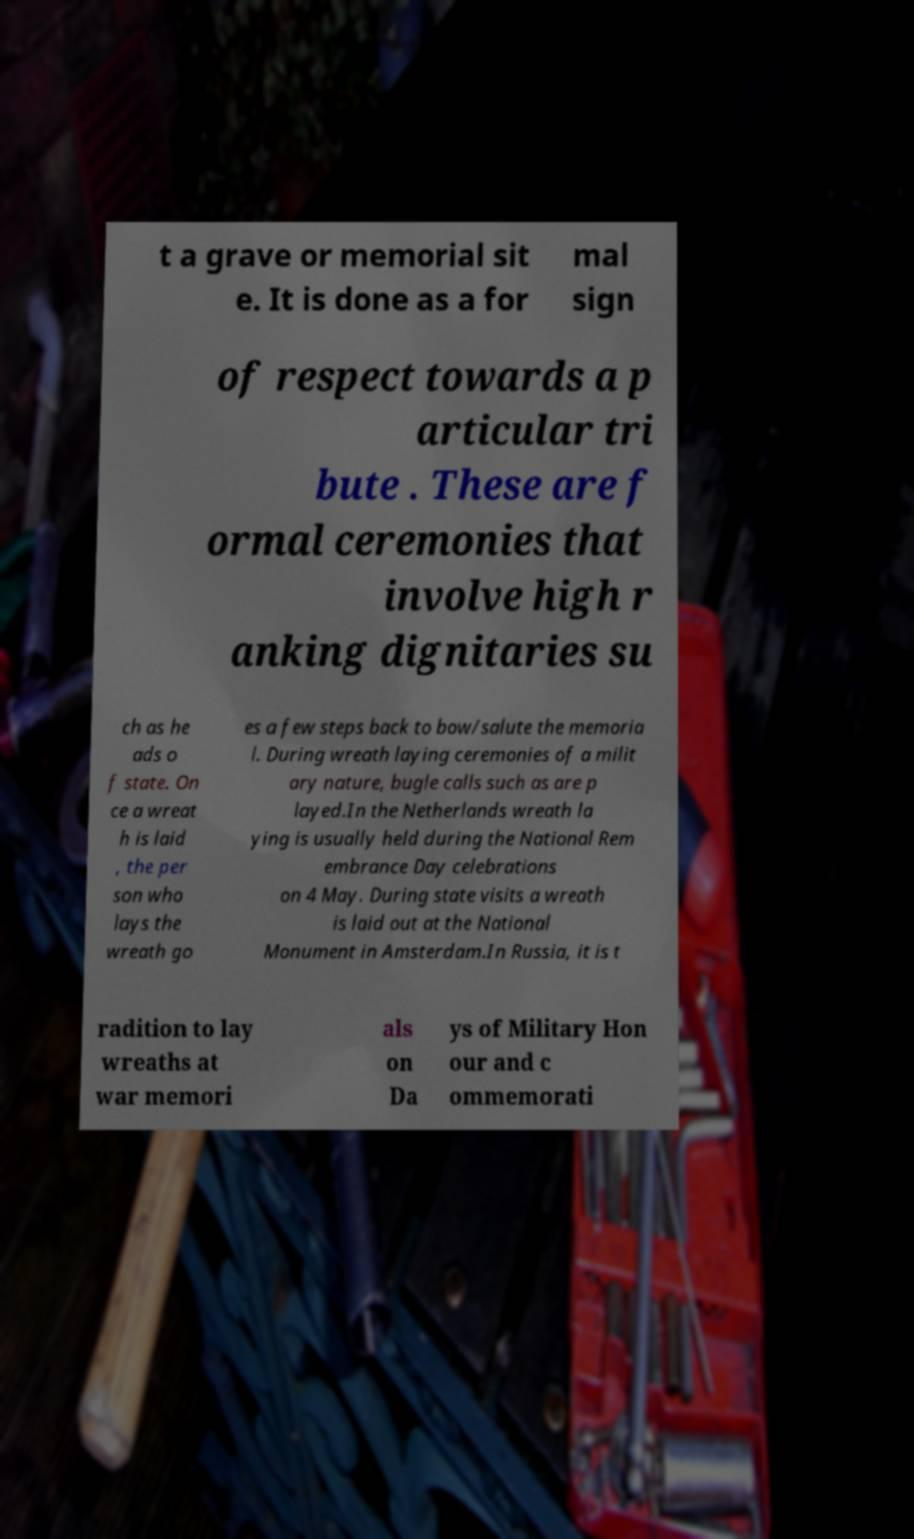Can you accurately transcribe the text from the provided image for me? t a grave or memorial sit e. It is done as a for mal sign of respect towards a p articular tri bute . These are f ormal ceremonies that involve high r anking dignitaries su ch as he ads o f state. On ce a wreat h is laid , the per son who lays the wreath go es a few steps back to bow/salute the memoria l. During wreath laying ceremonies of a milit ary nature, bugle calls such as are p layed.In the Netherlands wreath la ying is usually held during the National Rem embrance Day celebrations on 4 May. During state visits a wreath is laid out at the National Monument in Amsterdam.In Russia, it is t radition to lay wreaths at war memori als on Da ys of Military Hon our and c ommemorati 